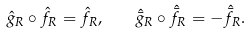Convert formula to latex. <formula><loc_0><loc_0><loc_500><loc_500>\hat { g } _ { R } \circ \hat { f } _ { R } = \hat { f } _ { R } , \quad \hat { \bar { g } } _ { R } \circ \hat { \bar { f } } _ { R } = - \hat { \bar { f } } _ { R } .</formula> 